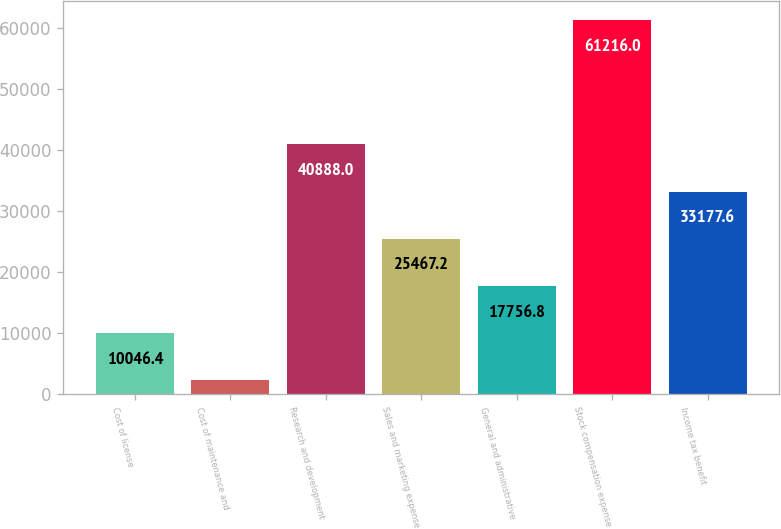Convert chart to OTSL. <chart><loc_0><loc_0><loc_500><loc_500><bar_chart><fcel>Cost of license<fcel>Cost of maintenance and<fcel>Research and development<fcel>Sales and marketing expense<fcel>General and administrative<fcel>Stock compensation expense<fcel>Income tax benefit<nl><fcel>10046.4<fcel>2336<fcel>40888<fcel>25467.2<fcel>17756.8<fcel>61216<fcel>33177.6<nl></chart> 